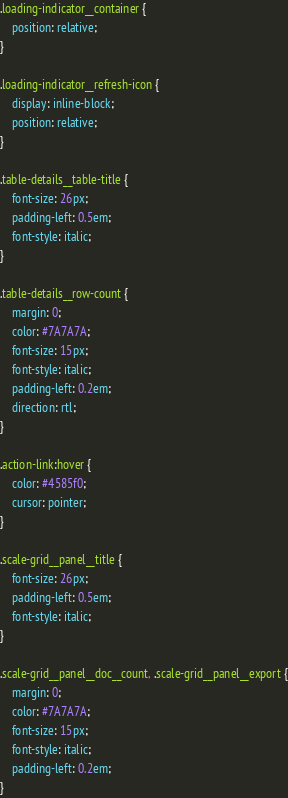Convert code to text. <code><loc_0><loc_0><loc_500><loc_500><_CSS_>.loading-indicator__container {
    position: relative;
}

.loading-indicator__refresh-icon {
    display: inline-block;
    position: relative;
}

.table-details__table-title {
    font-size: 26px;
    padding-left: 0.5em;
    font-style: italic;
}

.table-details__row-count {
    margin: 0;
    color: #7A7A7A;
    font-size: 15px;
    font-style: italic;
    padding-left: 0.2em;
    direction: rtl;
}

.action-link:hover {
    color: #4585f0;
    cursor: pointer;
}

.scale-grid__panel__title {
    font-size: 26px;
    padding-left: 0.5em;
    font-style: italic;
}

.scale-grid__panel__doc__count, .scale-grid__panel__export {
    margin: 0;
    color: #7A7A7A;
    font-size: 15px;
    font-style: italic;
    padding-left: 0.2em;
}</code> 